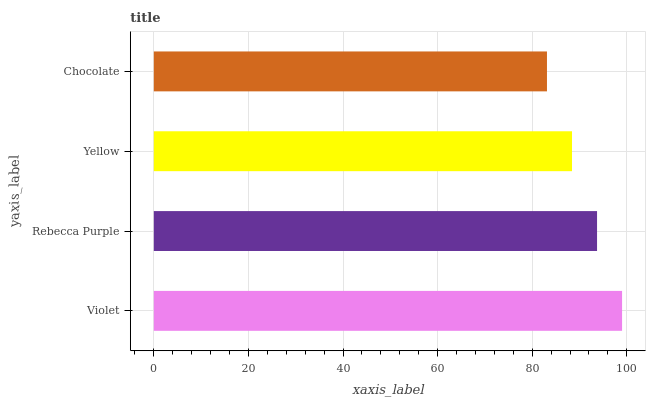Is Chocolate the minimum?
Answer yes or no. Yes. Is Violet the maximum?
Answer yes or no. Yes. Is Rebecca Purple the minimum?
Answer yes or no. No. Is Rebecca Purple the maximum?
Answer yes or no. No. Is Violet greater than Rebecca Purple?
Answer yes or no. Yes. Is Rebecca Purple less than Violet?
Answer yes or no. Yes. Is Rebecca Purple greater than Violet?
Answer yes or no. No. Is Violet less than Rebecca Purple?
Answer yes or no. No. Is Rebecca Purple the high median?
Answer yes or no. Yes. Is Yellow the low median?
Answer yes or no. Yes. Is Yellow the high median?
Answer yes or no. No. Is Chocolate the low median?
Answer yes or no. No. 